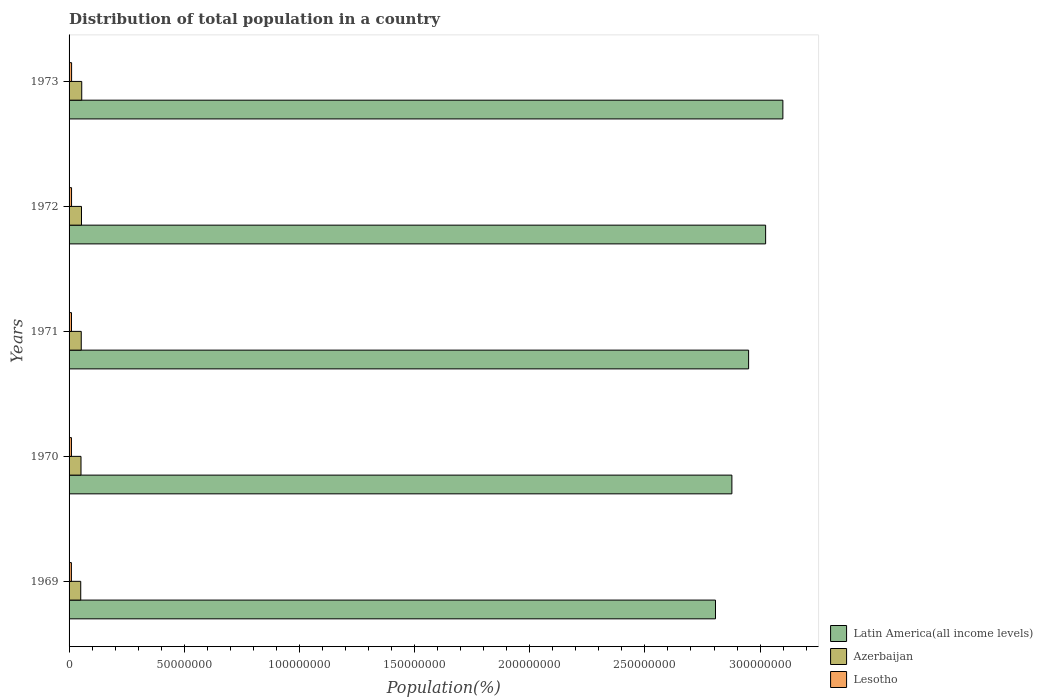How many different coloured bars are there?
Provide a short and direct response. 3. How many groups of bars are there?
Ensure brevity in your answer.  5. How many bars are there on the 1st tick from the top?
Provide a short and direct response. 3. What is the label of the 2nd group of bars from the top?
Make the answer very short. 1972. What is the population of in Latin America(all income levels) in 1971?
Your answer should be very brief. 2.95e+08. Across all years, what is the maximum population of in Latin America(all income levels)?
Your answer should be very brief. 3.10e+08. Across all years, what is the minimum population of in Latin America(all income levels)?
Offer a very short reply. 2.81e+08. In which year was the population of in Azerbaijan maximum?
Provide a succinct answer. 1973. In which year was the population of in Lesotho minimum?
Your answer should be compact. 1969. What is the total population of in Lesotho in the graph?
Provide a short and direct response. 5.27e+06. What is the difference between the population of in Lesotho in 1970 and that in 1972?
Offer a terse response. -4.30e+04. What is the difference between the population of in Azerbaijan in 1969 and the population of in Latin America(all income levels) in 1973?
Ensure brevity in your answer.  -3.05e+08. What is the average population of in Azerbaijan per year?
Your response must be concise. 5.28e+06. In the year 1970, what is the difference between the population of in Azerbaijan and population of in Lesotho?
Provide a short and direct response. 4.15e+06. What is the ratio of the population of in Latin America(all income levels) in 1971 to that in 1972?
Offer a terse response. 0.98. Is the population of in Lesotho in 1970 less than that in 1972?
Make the answer very short. Yes. Is the difference between the population of in Azerbaijan in 1970 and 1971 greater than the difference between the population of in Lesotho in 1970 and 1971?
Your answer should be very brief. No. What is the difference between the highest and the second highest population of in Lesotho?
Provide a short and direct response. 2.28e+04. What is the difference between the highest and the lowest population of in Latin America(all income levels)?
Ensure brevity in your answer.  2.93e+07. What does the 3rd bar from the top in 1969 represents?
Provide a succinct answer. Latin America(all income levels). What does the 2nd bar from the bottom in 1970 represents?
Give a very brief answer. Azerbaijan. How many bars are there?
Ensure brevity in your answer.  15. How many years are there in the graph?
Provide a short and direct response. 5. Does the graph contain any zero values?
Provide a short and direct response. No. What is the title of the graph?
Keep it short and to the point. Distribution of total population in a country. Does "Moldova" appear as one of the legend labels in the graph?
Make the answer very short. No. What is the label or title of the X-axis?
Make the answer very short. Population(%). What is the Population(%) of Latin America(all income levels) in 1969?
Offer a very short reply. 2.81e+08. What is the Population(%) of Azerbaijan in 1969?
Make the answer very short. 5.07e+06. What is the Population(%) in Lesotho in 1969?
Offer a terse response. 1.01e+06. What is the Population(%) of Latin America(all income levels) in 1970?
Your answer should be compact. 2.88e+08. What is the Population(%) of Azerbaijan in 1970?
Make the answer very short. 5.18e+06. What is the Population(%) in Lesotho in 1970?
Give a very brief answer. 1.03e+06. What is the Population(%) in Latin America(all income levels) in 1971?
Your response must be concise. 2.95e+08. What is the Population(%) in Azerbaijan in 1971?
Give a very brief answer. 5.29e+06. What is the Population(%) of Lesotho in 1971?
Your response must be concise. 1.05e+06. What is the Population(%) of Latin America(all income levels) in 1972?
Offer a very short reply. 3.02e+08. What is the Population(%) of Azerbaijan in 1972?
Your answer should be compact. 5.39e+06. What is the Population(%) of Lesotho in 1972?
Keep it short and to the point. 1.08e+06. What is the Population(%) of Latin America(all income levels) in 1973?
Make the answer very short. 3.10e+08. What is the Population(%) in Azerbaijan in 1973?
Give a very brief answer. 5.50e+06. What is the Population(%) of Lesotho in 1973?
Provide a short and direct response. 1.10e+06. Across all years, what is the maximum Population(%) of Latin America(all income levels)?
Provide a succinct answer. 3.10e+08. Across all years, what is the maximum Population(%) of Azerbaijan?
Provide a succinct answer. 5.50e+06. Across all years, what is the maximum Population(%) of Lesotho?
Make the answer very short. 1.10e+06. Across all years, what is the minimum Population(%) of Latin America(all income levels)?
Make the answer very short. 2.81e+08. Across all years, what is the minimum Population(%) of Azerbaijan?
Your answer should be very brief. 5.07e+06. Across all years, what is the minimum Population(%) in Lesotho?
Provide a succinct answer. 1.01e+06. What is the total Population(%) of Latin America(all income levels) in the graph?
Your answer should be very brief. 1.48e+09. What is the total Population(%) in Azerbaijan in the graph?
Your answer should be very brief. 2.64e+07. What is the total Population(%) in Lesotho in the graph?
Provide a short and direct response. 5.27e+06. What is the difference between the Population(%) of Latin America(all income levels) in 1969 and that in 1970?
Your answer should be very brief. -7.12e+06. What is the difference between the Population(%) in Azerbaijan in 1969 and that in 1970?
Your answer should be very brief. -1.12e+05. What is the difference between the Population(%) in Lesotho in 1969 and that in 1970?
Ensure brevity in your answer.  -2.09e+04. What is the difference between the Population(%) in Latin America(all income levels) in 1969 and that in 1971?
Offer a terse response. -1.44e+07. What is the difference between the Population(%) in Azerbaijan in 1969 and that in 1971?
Keep it short and to the point. -2.21e+05. What is the difference between the Population(%) of Lesotho in 1969 and that in 1971?
Your response must be concise. -4.22e+04. What is the difference between the Population(%) in Latin America(all income levels) in 1969 and that in 1972?
Make the answer very short. -2.18e+07. What is the difference between the Population(%) in Azerbaijan in 1969 and that in 1972?
Make the answer very short. -3.27e+05. What is the difference between the Population(%) in Lesotho in 1969 and that in 1972?
Offer a very short reply. -6.40e+04. What is the difference between the Population(%) in Latin America(all income levels) in 1969 and that in 1973?
Your response must be concise. -2.93e+07. What is the difference between the Population(%) in Azerbaijan in 1969 and that in 1973?
Keep it short and to the point. -4.30e+05. What is the difference between the Population(%) of Lesotho in 1969 and that in 1973?
Ensure brevity in your answer.  -8.67e+04. What is the difference between the Population(%) of Latin America(all income levels) in 1970 and that in 1971?
Your answer should be very brief. -7.26e+06. What is the difference between the Population(%) in Azerbaijan in 1970 and that in 1971?
Keep it short and to the point. -1.09e+05. What is the difference between the Population(%) in Lesotho in 1970 and that in 1971?
Give a very brief answer. -2.13e+04. What is the difference between the Population(%) in Latin America(all income levels) in 1970 and that in 1972?
Your answer should be compact. -1.46e+07. What is the difference between the Population(%) of Azerbaijan in 1970 and that in 1972?
Provide a succinct answer. -2.15e+05. What is the difference between the Population(%) in Lesotho in 1970 and that in 1972?
Make the answer very short. -4.30e+04. What is the difference between the Population(%) of Latin America(all income levels) in 1970 and that in 1973?
Provide a succinct answer. -2.21e+07. What is the difference between the Population(%) of Azerbaijan in 1970 and that in 1973?
Your answer should be compact. -3.18e+05. What is the difference between the Population(%) in Lesotho in 1970 and that in 1973?
Make the answer very short. -6.58e+04. What is the difference between the Population(%) of Latin America(all income levels) in 1971 and that in 1972?
Your answer should be very brief. -7.38e+06. What is the difference between the Population(%) of Azerbaijan in 1971 and that in 1972?
Ensure brevity in your answer.  -1.06e+05. What is the difference between the Population(%) of Lesotho in 1971 and that in 1972?
Offer a very short reply. -2.18e+04. What is the difference between the Population(%) in Latin America(all income levels) in 1971 and that in 1973?
Offer a very short reply. -1.49e+07. What is the difference between the Population(%) in Azerbaijan in 1971 and that in 1973?
Offer a terse response. -2.09e+05. What is the difference between the Population(%) of Lesotho in 1971 and that in 1973?
Make the answer very short. -4.45e+04. What is the difference between the Population(%) in Latin America(all income levels) in 1972 and that in 1973?
Give a very brief answer. -7.49e+06. What is the difference between the Population(%) in Azerbaijan in 1972 and that in 1973?
Offer a terse response. -1.03e+05. What is the difference between the Population(%) of Lesotho in 1972 and that in 1973?
Ensure brevity in your answer.  -2.28e+04. What is the difference between the Population(%) of Latin America(all income levels) in 1969 and the Population(%) of Azerbaijan in 1970?
Ensure brevity in your answer.  2.75e+08. What is the difference between the Population(%) in Latin America(all income levels) in 1969 and the Population(%) in Lesotho in 1970?
Offer a very short reply. 2.80e+08. What is the difference between the Population(%) in Azerbaijan in 1969 and the Population(%) in Lesotho in 1970?
Provide a short and direct response. 4.03e+06. What is the difference between the Population(%) in Latin America(all income levels) in 1969 and the Population(%) in Azerbaijan in 1971?
Ensure brevity in your answer.  2.75e+08. What is the difference between the Population(%) of Latin America(all income levels) in 1969 and the Population(%) of Lesotho in 1971?
Provide a short and direct response. 2.80e+08. What is the difference between the Population(%) of Azerbaijan in 1969 and the Population(%) of Lesotho in 1971?
Your answer should be very brief. 4.01e+06. What is the difference between the Population(%) of Latin America(all income levels) in 1969 and the Population(%) of Azerbaijan in 1972?
Provide a short and direct response. 2.75e+08. What is the difference between the Population(%) of Latin America(all income levels) in 1969 and the Population(%) of Lesotho in 1972?
Keep it short and to the point. 2.80e+08. What is the difference between the Population(%) of Azerbaijan in 1969 and the Population(%) of Lesotho in 1972?
Give a very brief answer. 3.99e+06. What is the difference between the Population(%) in Latin America(all income levels) in 1969 and the Population(%) in Azerbaijan in 1973?
Keep it short and to the point. 2.75e+08. What is the difference between the Population(%) of Latin America(all income levels) in 1969 and the Population(%) of Lesotho in 1973?
Keep it short and to the point. 2.80e+08. What is the difference between the Population(%) in Azerbaijan in 1969 and the Population(%) in Lesotho in 1973?
Give a very brief answer. 3.97e+06. What is the difference between the Population(%) of Latin America(all income levels) in 1970 and the Population(%) of Azerbaijan in 1971?
Your answer should be very brief. 2.82e+08. What is the difference between the Population(%) in Latin America(all income levels) in 1970 and the Population(%) in Lesotho in 1971?
Offer a terse response. 2.87e+08. What is the difference between the Population(%) of Azerbaijan in 1970 and the Population(%) of Lesotho in 1971?
Give a very brief answer. 4.12e+06. What is the difference between the Population(%) of Latin America(all income levels) in 1970 and the Population(%) of Azerbaijan in 1972?
Give a very brief answer. 2.82e+08. What is the difference between the Population(%) of Latin America(all income levels) in 1970 and the Population(%) of Lesotho in 1972?
Offer a terse response. 2.87e+08. What is the difference between the Population(%) in Azerbaijan in 1970 and the Population(%) in Lesotho in 1972?
Your response must be concise. 4.10e+06. What is the difference between the Population(%) of Latin America(all income levels) in 1970 and the Population(%) of Azerbaijan in 1973?
Your answer should be compact. 2.82e+08. What is the difference between the Population(%) in Latin America(all income levels) in 1970 and the Population(%) in Lesotho in 1973?
Offer a very short reply. 2.87e+08. What is the difference between the Population(%) in Azerbaijan in 1970 and the Population(%) in Lesotho in 1973?
Provide a short and direct response. 4.08e+06. What is the difference between the Population(%) in Latin America(all income levels) in 1971 and the Population(%) in Azerbaijan in 1972?
Offer a very short reply. 2.90e+08. What is the difference between the Population(%) of Latin America(all income levels) in 1971 and the Population(%) of Lesotho in 1972?
Your answer should be compact. 2.94e+08. What is the difference between the Population(%) of Azerbaijan in 1971 and the Population(%) of Lesotho in 1972?
Your response must be concise. 4.21e+06. What is the difference between the Population(%) in Latin America(all income levels) in 1971 and the Population(%) in Azerbaijan in 1973?
Offer a terse response. 2.90e+08. What is the difference between the Population(%) in Latin America(all income levels) in 1971 and the Population(%) in Lesotho in 1973?
Offer a very short reply. 2.94e+08. What is the difference between the Population(%) in Azerbaijan in 1971 and the Population(%) in Lesotho in 1973?
Your response must be concise. 4.19e+06. What is the difference between the Population(%) in Latin America(all income levels) in 1972 and the Population(%) in Azerbaijan in 1973?
Your answer should be very brief. 2.97e+08. What is the difference between the Population(%) of Latin America(all income levels) in 1972 and the Population(%) of Lesotho in 1973?
Give a very brief answer. 3.01e+08. What is the difference between the Population(%) in Azerbaijan in 1972 and the Population(%) in Lesotho in 1973?
Your answer should be very brief. 4.30e+06. What is the average Population(%) in Latin America(all income levels) per year?
Offer a terse response. 2.95e+08. What is the average Population(%) in Azerbaijan per year?
Ensure brevity in your answer.  5.28e+06. What is the average Population(%) in Lesotho per year?
Ensure brevity in your answer.  1.05e+06. In the year 1969, what is the difference between the Population(%) in Latin America(all income levels) and Population(%) in Azerbaijan?
Offer a terse response. 2.76e+08. In the year 1969, what is the difference between the Population(%) of Latin America(all income levels) and Population(%) of Lesotho?
Offer a very short reply. 2.80e+08. In the year 1969, what is the difference between the Population(%) in Azerbaijan and Population(%) in Lesotho?
Your answer should be compact. 4.05e+06. In the year 1970, what is the difference between the Population(%) of Latin America(all income levels) and Population(%) of Azerbaijan?
Ensure brevity in your answer.  2.83e+08. In the year 1970, what is the difference between the Population(%) in Latin America(all income levels) and Population(%) in Lesotho?
Provide a succinct answer. 2.87e+08. In the year 1970, what is the difference between the Population(%) of Azerbaijan and Population(%) of Lesotho?
Ensure brevity in your answer.  4.15e+06. In the year 1971, what is the difference between the Population(%) of Latin America(all income levels) and Population(%) of Azerbaijan?
Your response must be concise. 2.90e+08. In the year 1971, what is the difference between the Population(%) of Latin America(all income levels) and Population(%) of Lesotho?
Provide a short and direct response. 2.94e+08. In the year 1971, what is the difference between the Population(%) of Azerbaijan and Population(%) of Lesotho?
Offer a very short reply. 4.23e+06. In the year 1972, what is the difference between the Population(%) in Latin America(all income levels) and Population(%) in Azerbaijan?
Offer a very short reply. 2.97e+08. In the year 1972, what is the difference between the Population(%) in Latin America(all income levels) and Population(%) in Lesotho?
Give a very brief answer. 3.01e+08. In the year 1972, what is the difference between the Population(%) in Azerbaijan and Population(%) in Lesotho?
Give a very brief answer. 4.32e+06. In the year 1973, what is the difference between the Population(%) of Latin America(all income levels) and Population(%) of Azerbaijan?
Your answer should be compact. 3.04e+08. In the year 1973, what is the difference between the Population(%) of Latin America(all income levels) and Population(%) of Lesotho?
Your response must be concise. 3.09e+08. In the year 1973, what is the difference between the Population(%) in Azerbaijan and Population(%) in Lesotho?
Provide a short and direct response. 4.40e+06. What is the ratio of the Population(%) of Latin America(all income levels) in 1969 to that in 1970?
Keep it short and to the point. 0.98. What is the ratio of the Population(%) of Azerbaijan in 1969 to that in 1970?
Provide a short and direct response. 0.98. What is the ratio of the Population(%) of Lesotho in 1969 to that in 1970?
Make the answer very short. 0.98. What is the ratio of the Population(%) in Latin America(all income levels) in 1969 to that in 1971?
Offer a terse response. 0.95. What is the ratio of the Population(%) of Azerbaijan in 1969 to that in 1971?
Make the answer very short. 0.96. What is the ratio of the Population(%) of Lesotho in 1969 to that in 1971?
Provide a short and direct response. 0.96. What is the ratio of the Population(%) of Latin America(all income levels) in 1969 to that in 1972?
Provide a short and direct response. 0.93. What is the ratio of the Population(%) of Azerbaijan in 1969 to that in 1972?
Provide a short and direct response. 0.94. What is the ratio of the Population(%) in Lesotho in 1969 to that in 1972?
Keep it short and to the point. 0.94. What is the ratio of the Population(%) in Latin America(all income levels) in 1969 to that in 1973?
Provide a short and direct response. 0.91. What is the ratio of the Population(%) in Azerbaijan in 1969 to that in 1973?
Offer a terse response. 0.92. What is the ratio of the Population(%) of Lesotho in 1969 to that in 1973?
Offer a very short reply. 0.92. What is the ratio of the Population(%) in Latin America(all income levels) in 1970 to that in 1971?
Your answer should be compact. 0.98. What is the ratio of the Population(%) in Azerbaijan in 1970 to that in 1971?
Give a very brief answer. 0.98. What is the ratio of the Population(%) of Lesotho in 1970 to that in 1971?
Make the answer very short. 0.98. What is the ratio of the Population(%) of Latin America(all income levels) in 1970 to that in 1972?
Your answer should be very brief. 0.95. What is the ratio of the Population(%) of Azerbaijan in 1970 to that in 1972?
Offer a terse response. 0.96. What is the ratio of the Population(%) of Azerbaijan in 1970 to that in 1973?
Your answer should be compact. 0.94. What is the ratio of the Population(%) in Lesotho in 1970 to that in 1973?
Offer a terse response. 0.94. What is the ratio of the Population(%) of Latin America(all income levels) in 1971 to that in 1972?
Keep it short and to the point. 0.98. What is the ratio of the Population(%) of Azerbaijan in 1971 to that in 1972?
Keep it short and to the point. 0.98. What is the ratio of the Population(%) of Lesotho in 1971 to that in 1972?
Your answer should be very brief. 0.98. What is the ratio of the Population(%) in Lesotho in 1971 to that in 1973?
Provide a short and direct response. 0.96. What is the ratio of the Population(%) of Latin America(all income levels) in 1972 to that in 1973?
Ensure brevity in your answer.  0.98. What is the ratio of the Population(%) of Azerbaijan in 1972 to that in 1973?
Keep it short and to the point. 0.98. What is the ratio of the Population(%) in Lesotho in 1972 to that in 1973?
Provide a short and direct response. 0.98. What is the difference between the highest and the second highest Population(%) in Latin America(all income levels)?
Provide a short and direct response. 7.49e+06. What is the difference between the highest and the second highest Population(%) in Azerbaijan?
Your answer should be very brief. 1.03e+05. What is the difference between the highest and the second highest Population(%) of Lesotho?
Keep it short and to the point. 2.28e+04. What is the difference between the highest and the lowest Population(%) in Latin America(all income levels)?
Provide a short and direct response. 2.93e+07. What is the difference between the highest and the lowest Population(%) of Azerbaijan?
Offer a terse response. 4.30e+05. What is the difference between the highest and the lowest Population(%) in Lesotho?
Give a very brief answer. 8.67e+04. 